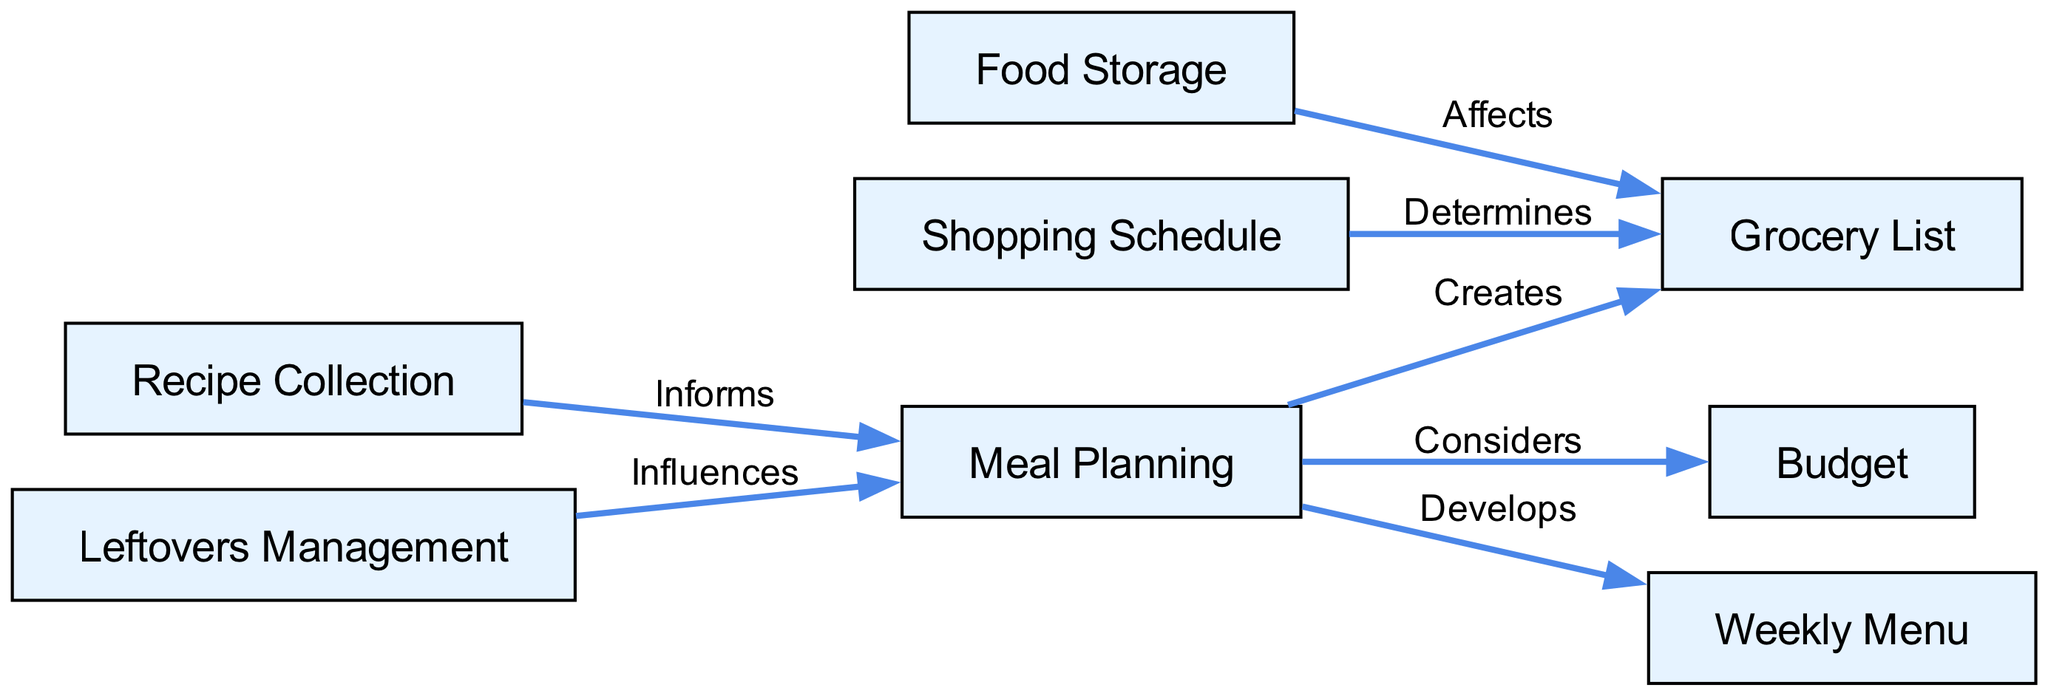What is the total number of nodes in the diagram? The diagram lists eight distinct nodes representing different aspects of meal planning and grocery shopping.
Answer: Eight Which node is created by meal planning? The edge shows that meal planning creates a grocery list.
Answer: Grocery List What does meal planning consider? The edges leading from meal planning show that it considers a budget.
Answer: Budget Which two aspects influence meal planning? The edges indicate that leftovers management and recipe collection influence meal planning.
Answer: Leftovers Management, Recipe Collection What relationship does food storage have with the grocery list? The edge between food storage and grocery list indicates that food storage affects the grocery list.
Answer: Affects How does the shopping schedule relate to the grocery list? The diagram shows a direct relationship where the shopping schedule determines the grocery list.
Answer: Determines Which node develops the weekly menu? The edge indicates that meal planning develops a weekly menu.
Answer: Weekly Menu What is the total number of edges in the diagram? By counting the lines that connect the nodes, the diagram shows a total of seven edges.
Answer: Seven 